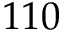<formula> <loc_0><loc_0><loc_500><loc_500>1 1 0</formula> 